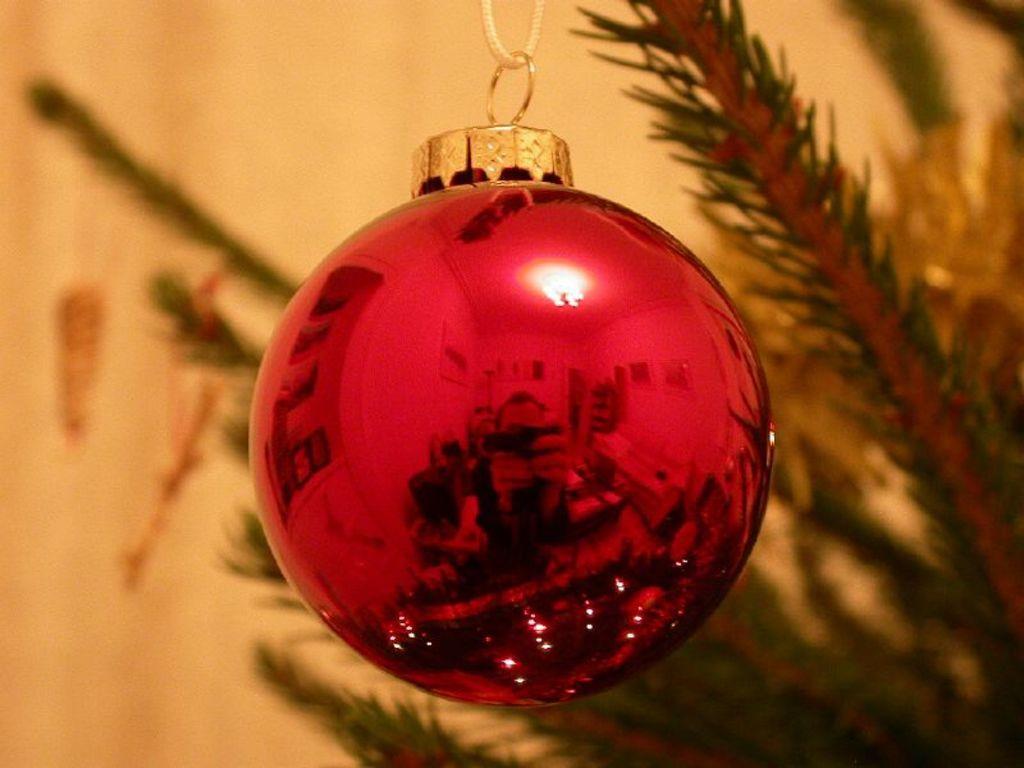How would you summarize this image in a sentence or two? In this image we can see an object which is in spherical shape and it is tied to a thread with the help of an object attached to it. In the background we can see a plant on the right side and wall. 